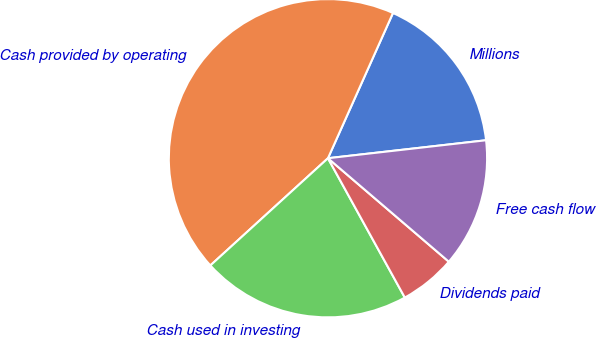<chart> <loc_0><loc_0><loc_500><loc_500><pie_chart><fcel>Millions<fcel>Cash provided by operating<fcel>Cash used in investing<fcel>Dividends paid<fcel>Free cash flow<nl><fcel>16.5%<fcel>43.47%<fcel>21.26%<fcel>5.71%<fcel>13.07%<nl></chart> 